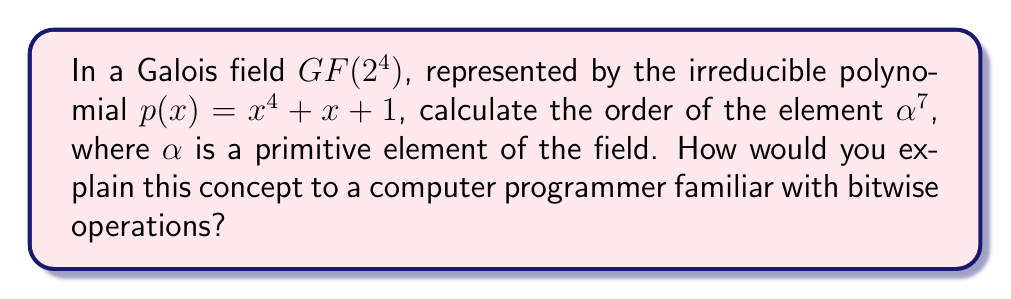What is the answer to this math problem? To explain this to a computer programmer, we can break it down into steps similar to processing binary data:

1) First, understand that $GF(2^4)$ is like working with 4-bit numbers, where addition is XOR and multiplication is similar to polynomial multiplication mod 2.

2) The order of an element is the smallest positive integer $n$ such that $(\alpha^7)^n = 1$. This is similar to finding the cycle length in a pseudo-random number generator.

3) To find the order, we need to compute powers of $\alpha^7$ until we get 1:

   $(\alpha^7)^1 = \alpha^7$
   $(\alpha^7)^2 = \alpha^{14}$
   $(\alpha^7)^3 = \alpha^{21}$
   ...

4) In $GF(2^4)$, the maximum order of any element is $2^4 - 1 = 15$, because $\alpha^{15} = 1$ for any non-zero element.

5) We can simplify our calculations using the property $\alpha^{15} = 1$:

   $\alpha^7 \equiv \alpha^7 \pmod{15}$
   $\alpha^{14} \equiv \alpha^{14} \pmod{15}$
   $\alpha^{21} \equiv \alpha^6 \pmod{15}$
   $\alpha^{28} \equiv \alpha^{13} \pmod{15}$
   $\alpha^{35} \equiv \alpha^5 \pmod{15}$
   $\alpha^{42} \equiv \alpha^{12} \pmod{15}$
   $\alpha^{49} \equiv \alpha^4 \pmod{15}$
   $\alpha^{56} \equiv \alpha^{11} \pmod{15}$
   $\alpha^{63} \equiv \alpha^3 \pmod{15}$
   $\alpha^{70} \equiv \alpha^{10} \pmod{15}$
   $\alpha^{77} \equiv \alpha^2 \pmod{15}$
   $\alpha^{84} \equiv \alpha^9 \pmod{15}$
   $\alpha^{91} \equiv \alpha \pmod{15}$
   $\alpha^{98} \equiv \alpha^8 \pmod{15}$
   $\alpha^{105} \equiv 1 \pmod{15}$

6) We see that $(\alpha^7)^{15} = 1$, and this is the smallest such power.

Therefore, the order of $\alpha^7$ is 15.
Answer: 15 